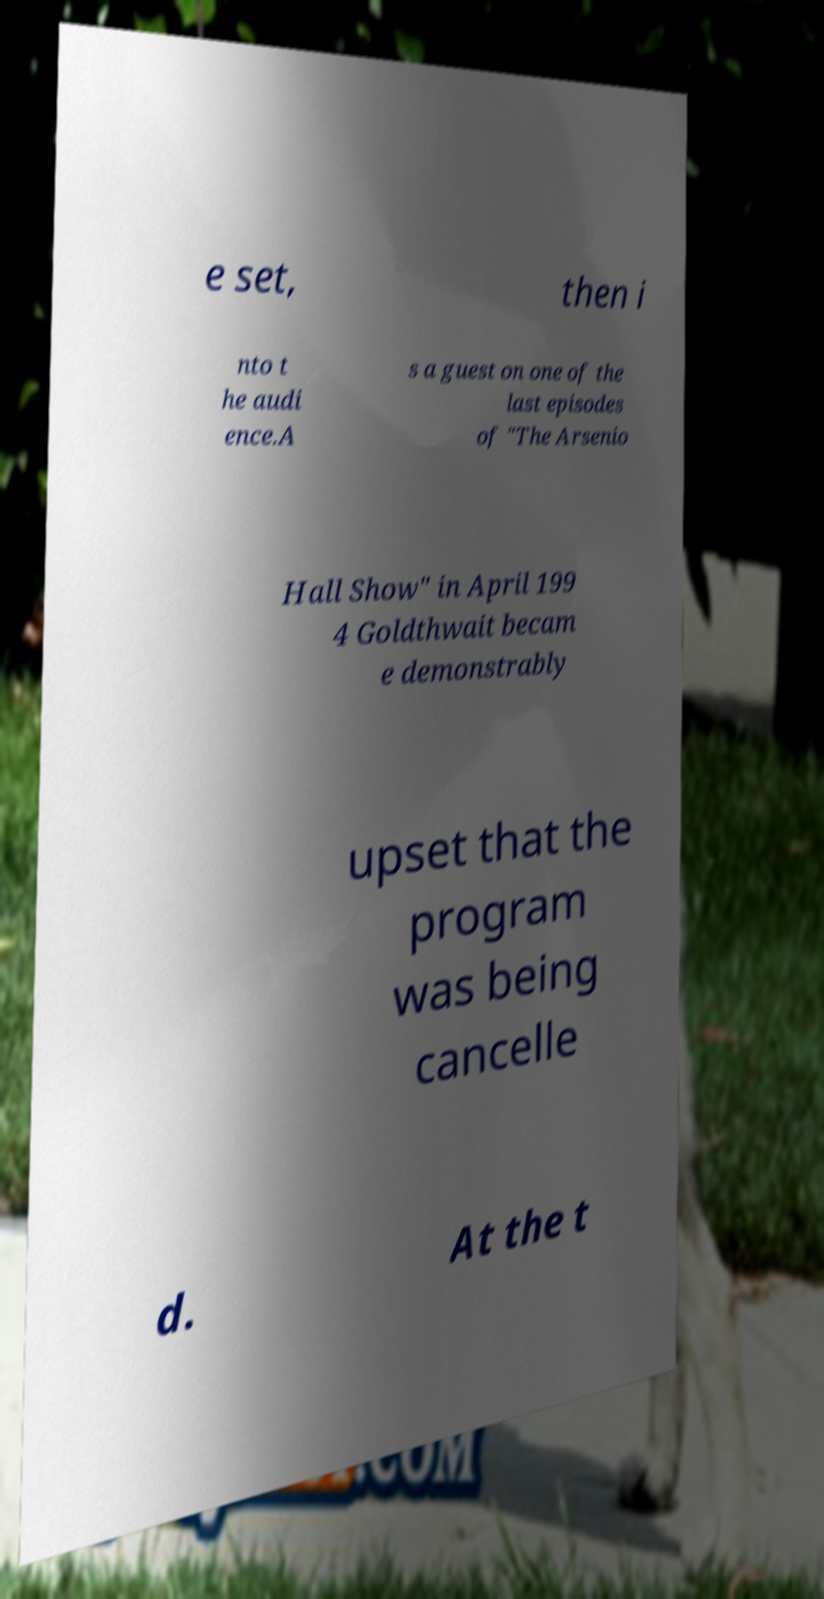Can you accurately transcribe the text from the provided image for me? e set, then i nto t he audi ence.A s a guest on one of the last episodes of "The Arsenio Hall Show" in April 199 4 Goldthwait becam e demonstrably upset that the program was being cancelle d. At the t 